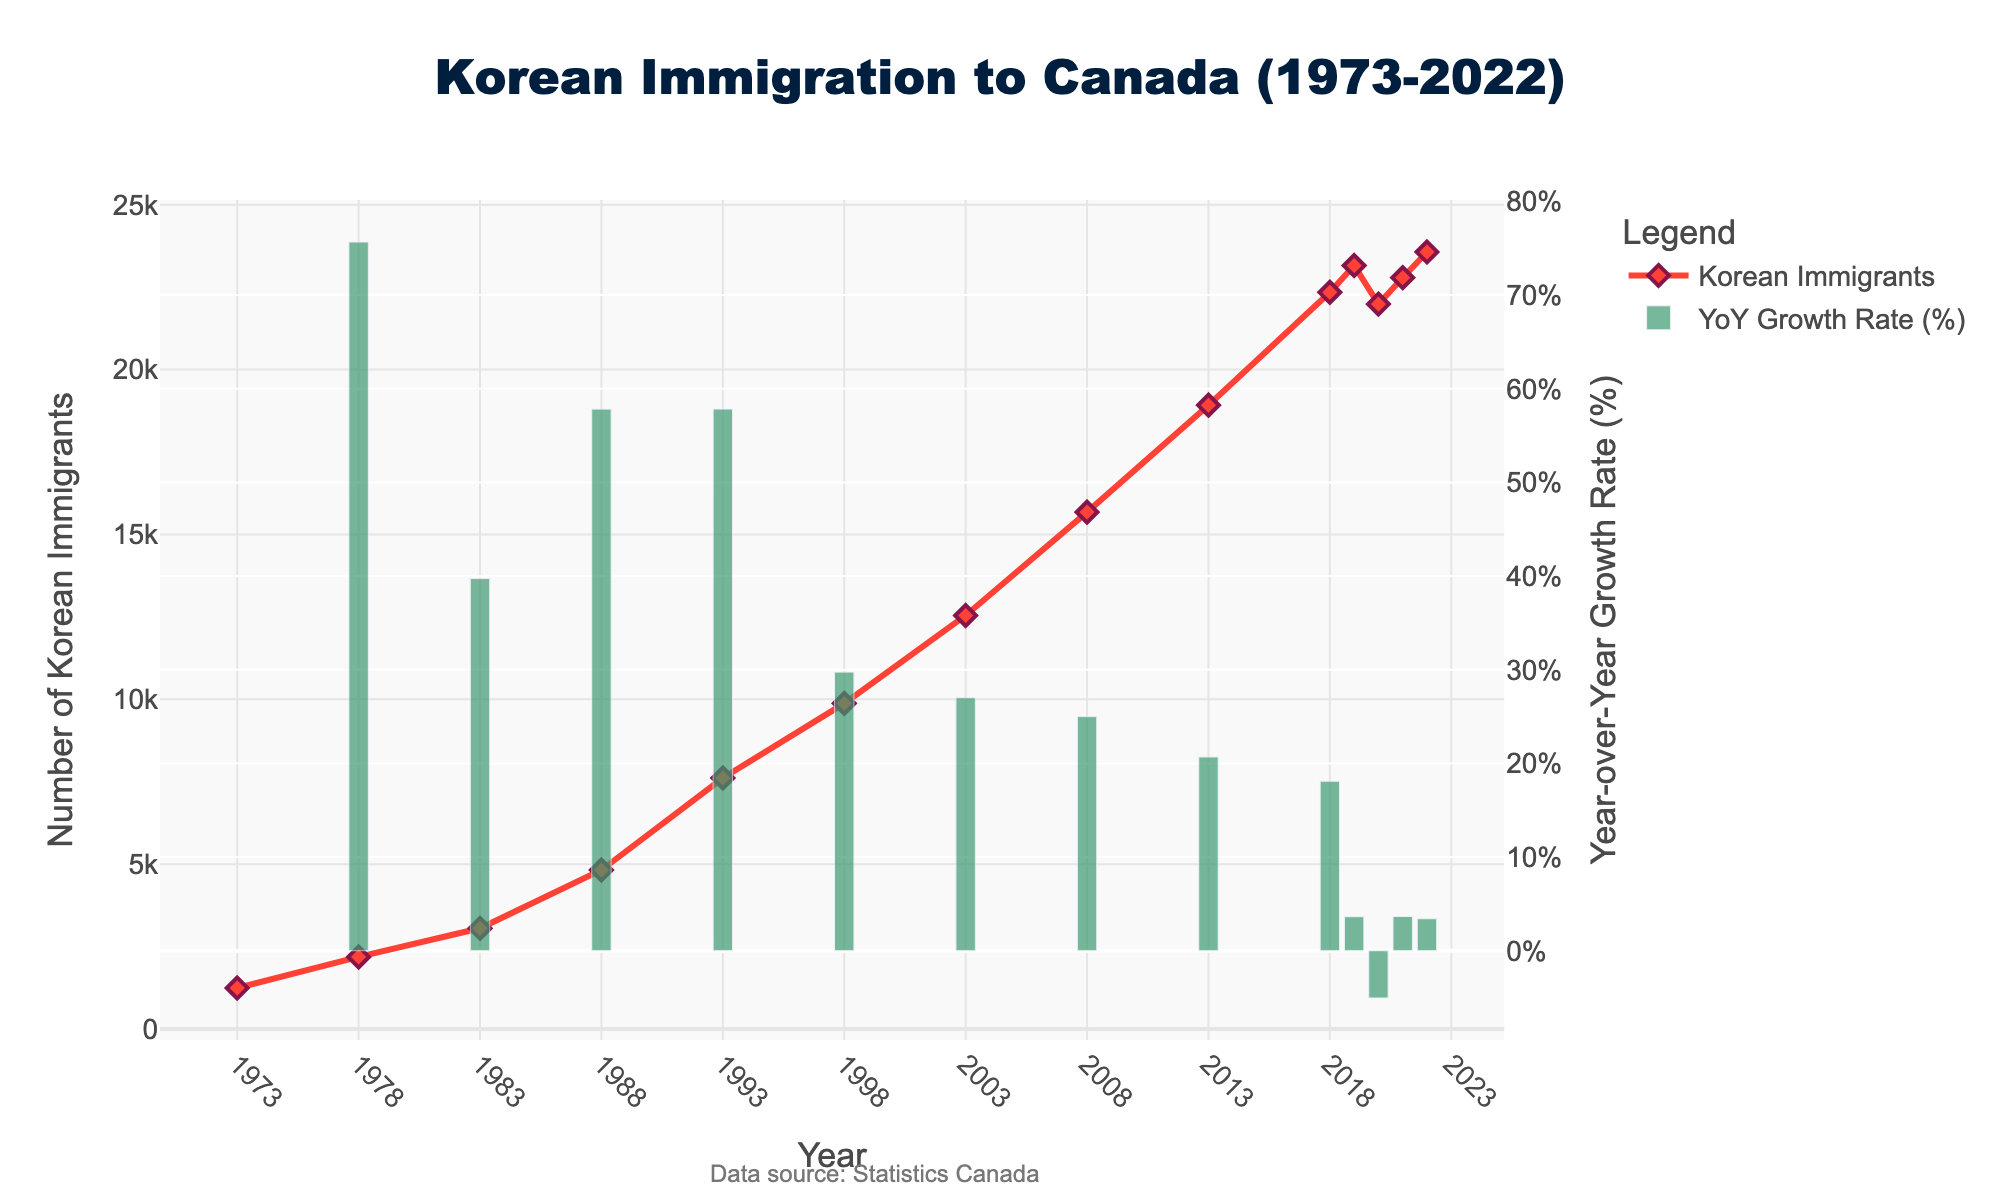What was the number of Korean immigrants to Canada in 2008? Look at the value on the red line (Korean Immigrants) for the year 2008 on the x-axis.
Answer: 15678 Did the number of Korean immigrants increase or decrease from 2019 to 2020? Compare the height of the red line (Korean Immigrants) between the years 2019 and 2020. The value decreases from 2019 to 2020.
Answer: Decrease Which year had the highest year-over-year growth rate in Korean immigration to Canada? Examine the green bars (YoY Growth Rate) and find the one with the greatest height.
Answer: 1988 What is the approximate year-over-year growth rate for Korean immigrants in 1993? Locate the green bar for the year 1993 and read the height on the secondary y-axis (%).
Answer: About 58% What was the average number of Korean immigrants per year in the 1990s? Identify the number of Korean immigrants for each year in the 1990s (1990-1999), sum them, and divide by the number of years. (7612 in 1993 and 9876 in 1998) Average = (7612 + 9876) / 2 = 12494 / 2
Answer: 8744 Compare the number of Korean immigrants in 1983 and 2013. Look at the values on the red line (Korean Immigrants) for the years 1983 and 2013 and compare them.
Answer: More in 2013 Was the year 2021 a recovery year after the dip in 2020 for Korean immigration? Compare the values on the red line (Korean Immigrants) of 2020 and 2021. The value increases from 2020 to 2021, showing a recovery.
Answer: Yes What visual feature indicates the number of Korean immigrants? The red line with diamond markers represents the number of Korean immigrants on the primary y-axis.
Answer: Red line with diamond markers Approximately how much did the number of Korean immigrants grow from 1998 to 2003? Subtract the number of Korean immigrants in 1998 from the number in 2003: 12543 - 9876
Answer: About 2667 Which color represents the year-over-year growth rate? The green bars indicate the year-over-year growth rate on the secondary y-axis.
Answer: Green bars 